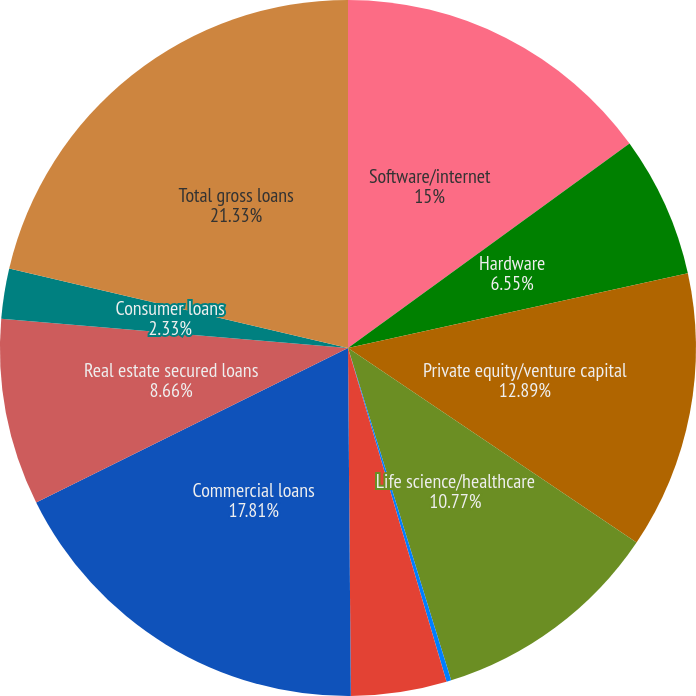Convert chart. <chart><loc_0><loc_0><loc_500><loc_500><pie_chart><fcel>Software/internet<fcel>Hardware<fcel>Private equity/venture capital<fcel>Life science/healthcare<fcel>Premium wine<fcel>Other<fcel>Commercial loans<fcel>Real estate secured loans<fcel>Consumer loans<fcel>Total gross loans<nl><fcel>15.0%<fcel>6.55%<fcel>12.89%<fcel>10.77%<fcel>0.22%<fcel>4.44%<fcel>17.81%<fcel>8.66%<fcel>2.33%<fcel>21.33%<nl></chart> 